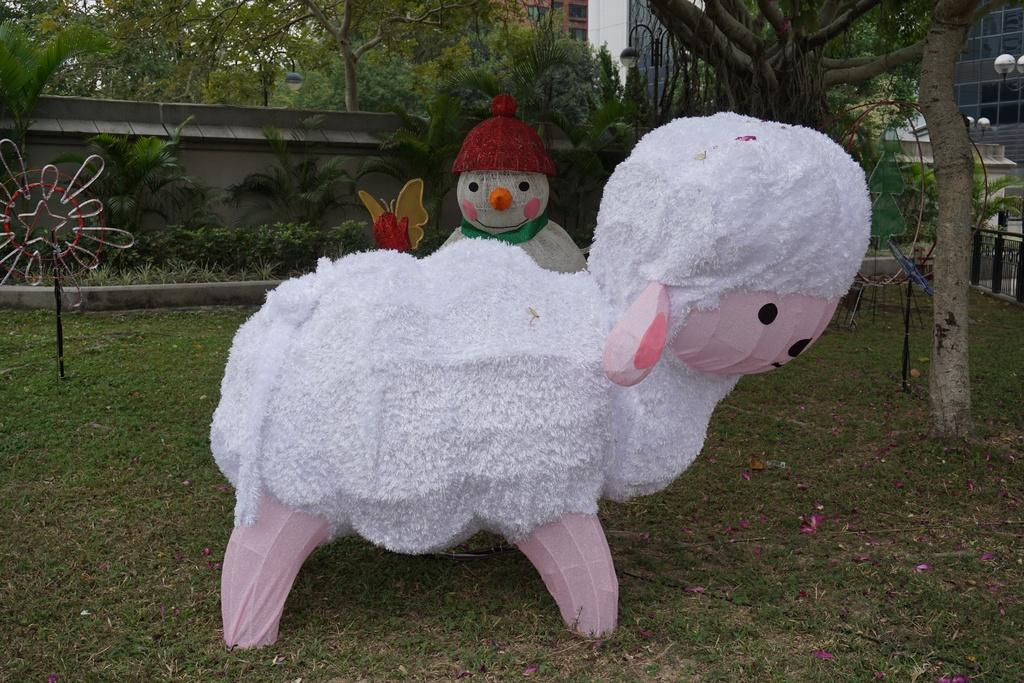What is the main subject in the foreground of the image? There is a model of a ship and a snowman in the foreground of the image. What can be seen in the background of the image? There are trees, plants, poles, and buildings in the background of the image. What sense does the snowman use to detect the presence of bears in the image? There are no bears present in the image, and therefore the snowman does not need to use any sense to detect them. 